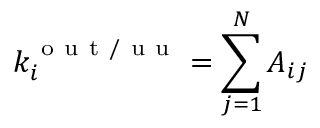Convert formula to latex. <formula><loc_0><loc_0><loc_500><loc_500>k _ { i } ^ { o u t / u u } = \sum _ { j = 1 } ^ { N } A _ { i j }</formula> 